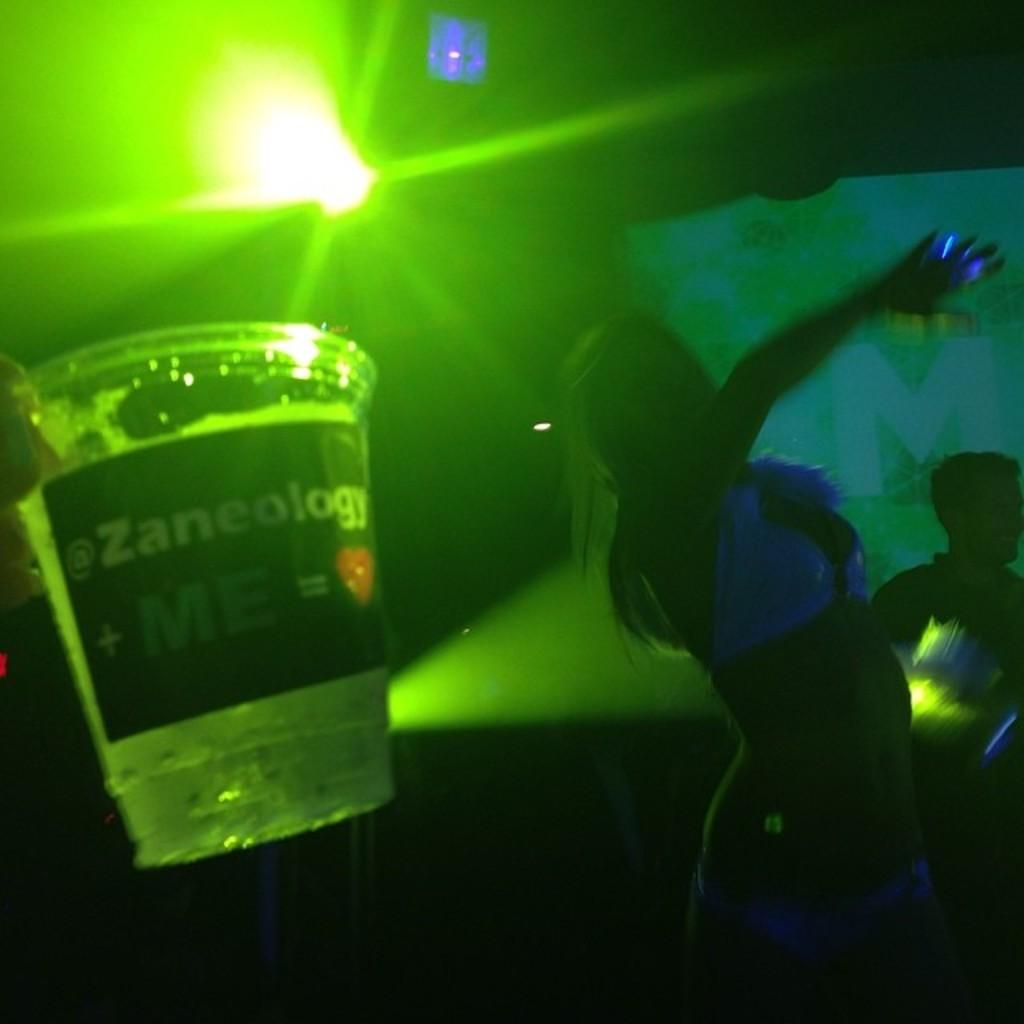What is the woman in the image doing? The woman is dancing in the image. What can be seen on the table or surface next to the woman? There is a glass with a label in the image. What is the color of the light coming from the glass? The glass has a green light. Can you describe the person in the background of the image? There is a person standing in the background of the image. What type of plot is the woman dancing on in the image? There is no plot visible in the image; the woman is dancing on a surface or floor. 